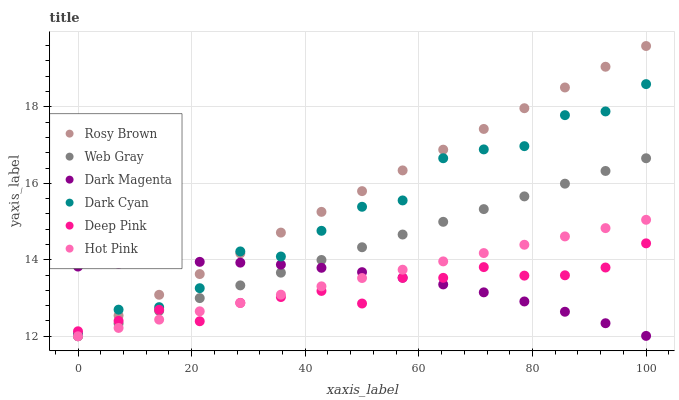Does Deep Pink have the minimum area under the curve?
Answer yes or no. Yes. Does Rosy Brown have the maximum area under the curve?
Answer yes or no. Yes. Does Dark Magenta have the minimum area under the curve?
Answer yes or no. No. Does Dark Magenta have the maximum area under the curve?
Answer yes or no. No. Is Hot Pink the smoothest?
Answer yes or no. Yes. Is Dark Cyan the roughest?
Answer yes or no. Yes. Is Dark Magenta the smoothest?
Answer yes or no. No. Is Dark Magenta the roughest?
Answer yes or no. No. Does Web Gray have the lowest value?
Answer yes or no. Yes. Does Dark Magenta have the lowest value?
Answer yes or no. No. Does Rosy Brown have the highest value?
Answer yes or no. Yes. Does Dark Magenta have the highest value?
Answer yes or no. No. Is Hot Pink less than Dark Cyan?
Answer yes or no. Yes. Is Dark Cyan greater than Hot Pink?
Answer yes or no. Yes. Does Hot Pink intersect Rosy Brown?
Answer yes or no. Yes. Is Hot Pink less than Rosy Brown?
Answer yes or no. No. Is Hot Pink greater than Rosy Brown?
Answer yes or no. No. Does Hot Pink intersect Dark Cyan?
Answer yes or no. No. 